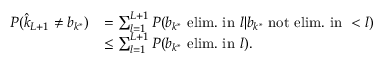Convert formula to latex. <formula><loc_0><loc_0><loc_500><loc_500>\begin{array} { r l } { P ( \hat { k } _ { L + 1 } \ne b _ { k ^ { * } } ) } & { = \sum _ { l = 1 } ^ { L + 1 } P ( b _ { k ^ { * } } e l i m . i n l | b _ { k ^ { * } } n o t e l i m . i n < l ) } \\ & { \leq \sum _ { l = 1 } ^ { L + 1 } P ( b _ { k ^ { * } } e l i m . i n l ) . } \end{array}</formula> 